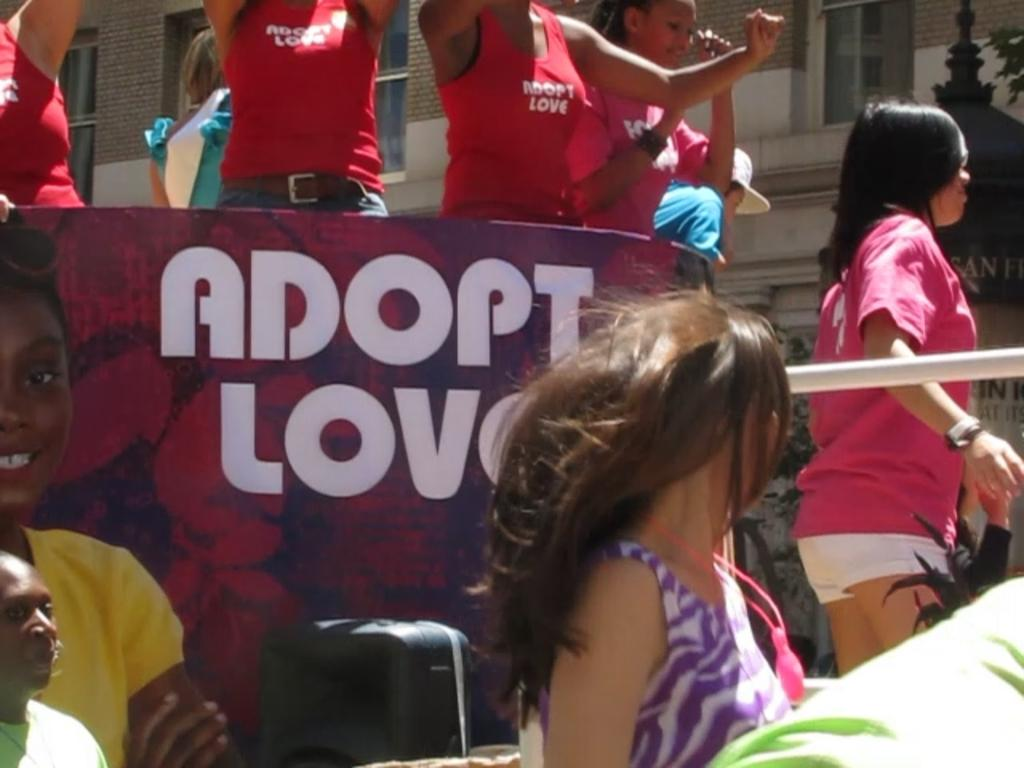<image>
Relay a brief, clear account of the picture shown. Women in red tank tops are standing above a sign that says Adopt Love. 